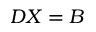<formula> <loc_0><loc_0><loc_500><loc_500>D X = B</formula> 